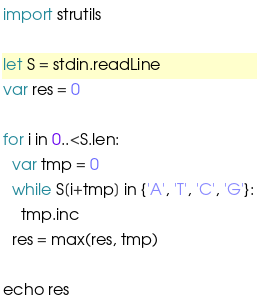<code> <loc_0><loc_0><loc_500><loc_500><_Nim_>import strutils

let S = stdin.readLine
var res = 0

for i in 0..<S.len:
  var tmp = 0
  while S[i+tmp] in {'A', 'T', 'C', 'G'}:
    tmp.inc
  res = max(res, tmp)

echo res
</code> 